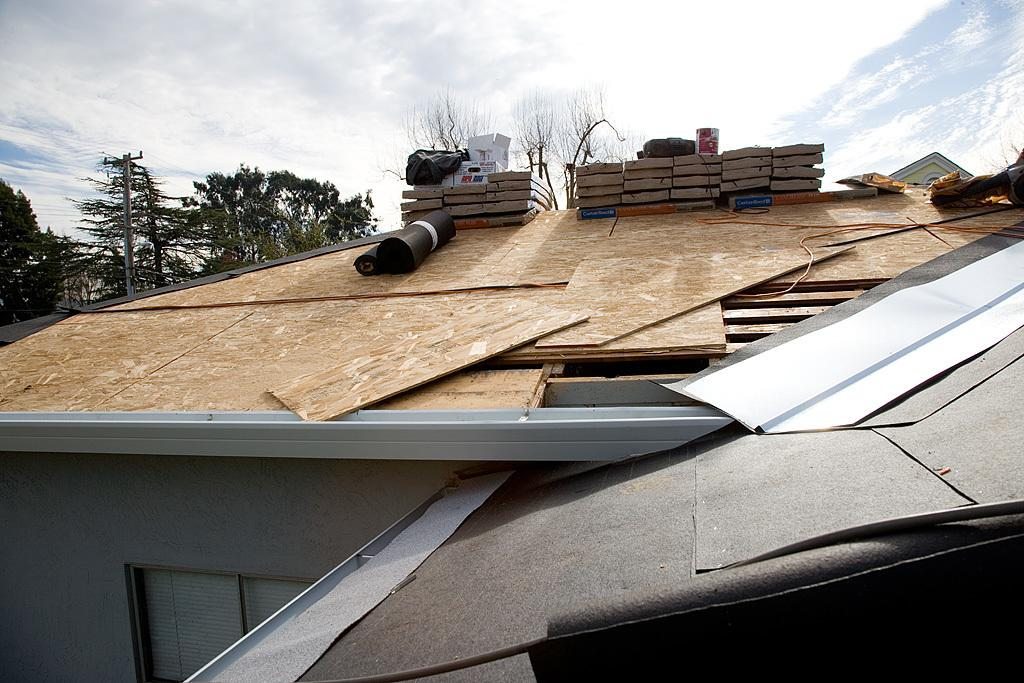What type of material is used for the planks in the image? The planks in the image are made of wood. What objects are present in the image besides the wooden planks? There are containers and rolled mats in the image. What can be seen in the background of the image? The background of the image includes sky, clouds, trees, electric poles, and electric cables. How many different types of objects are visible in the background? There are three different types of objects visible in the background: trees, electric poles, and electric cables. What type of lace is used to decorate the containers in the image? There is no lace present on the containers in the image. Is there a coat visible on any of the rolled mats in the image? There is no coat visible on any of the rolled mats in the image. 